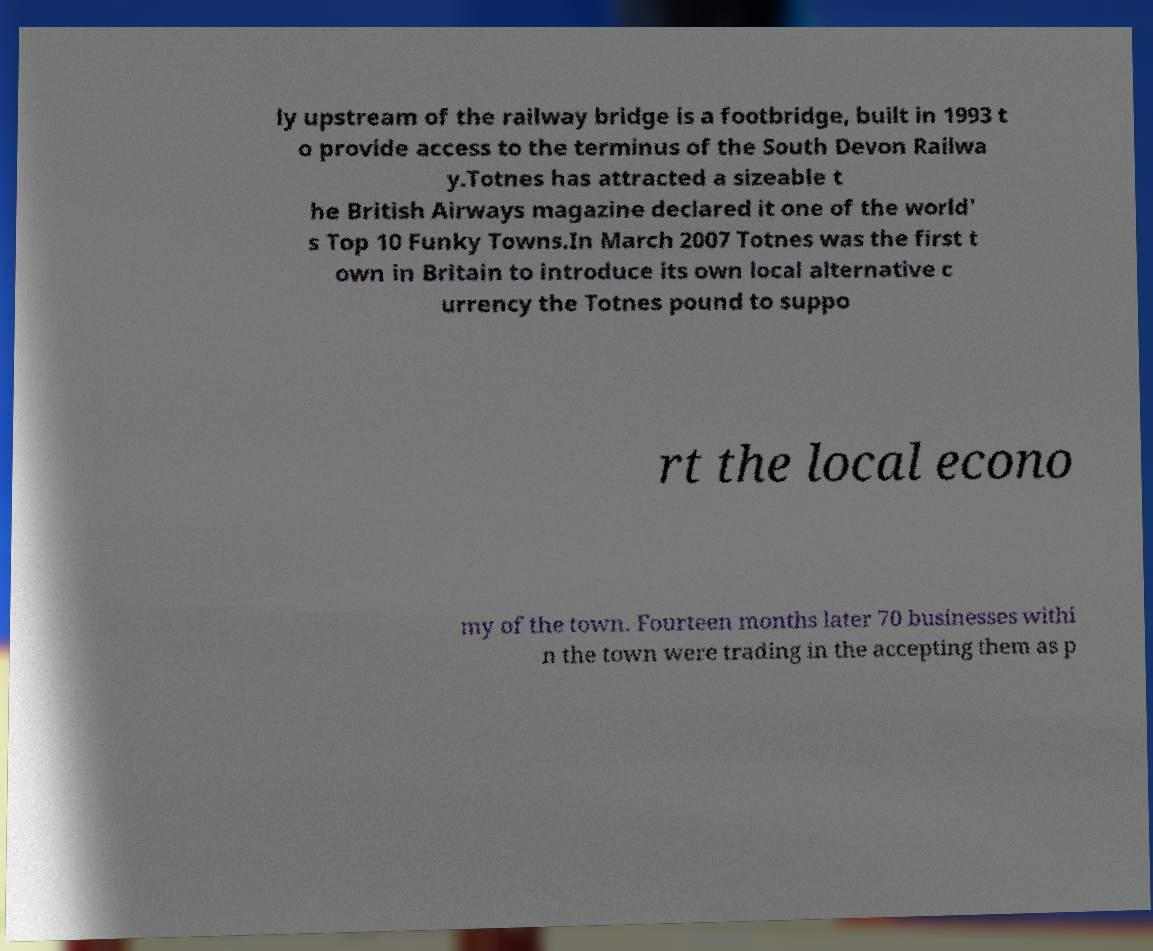I need the written content from this picture converted into text. Can you do that? ly upstream of the railway bridge is a footbridge, built in 1993 t o provide access to the terminus of the South Devon Railwa y.Totnes has attracted a sizeable t he British Airways magazine declared it one of the world' s Top 10 Funky Towns.In March 2007 Totnes was the first t own in Britain to introduce its own local alternative c urrency the Totnes pound to suppo rt the local econo my of the town. Fourteen months later 70 businesses withi n the town were trading in the accepting them as p 